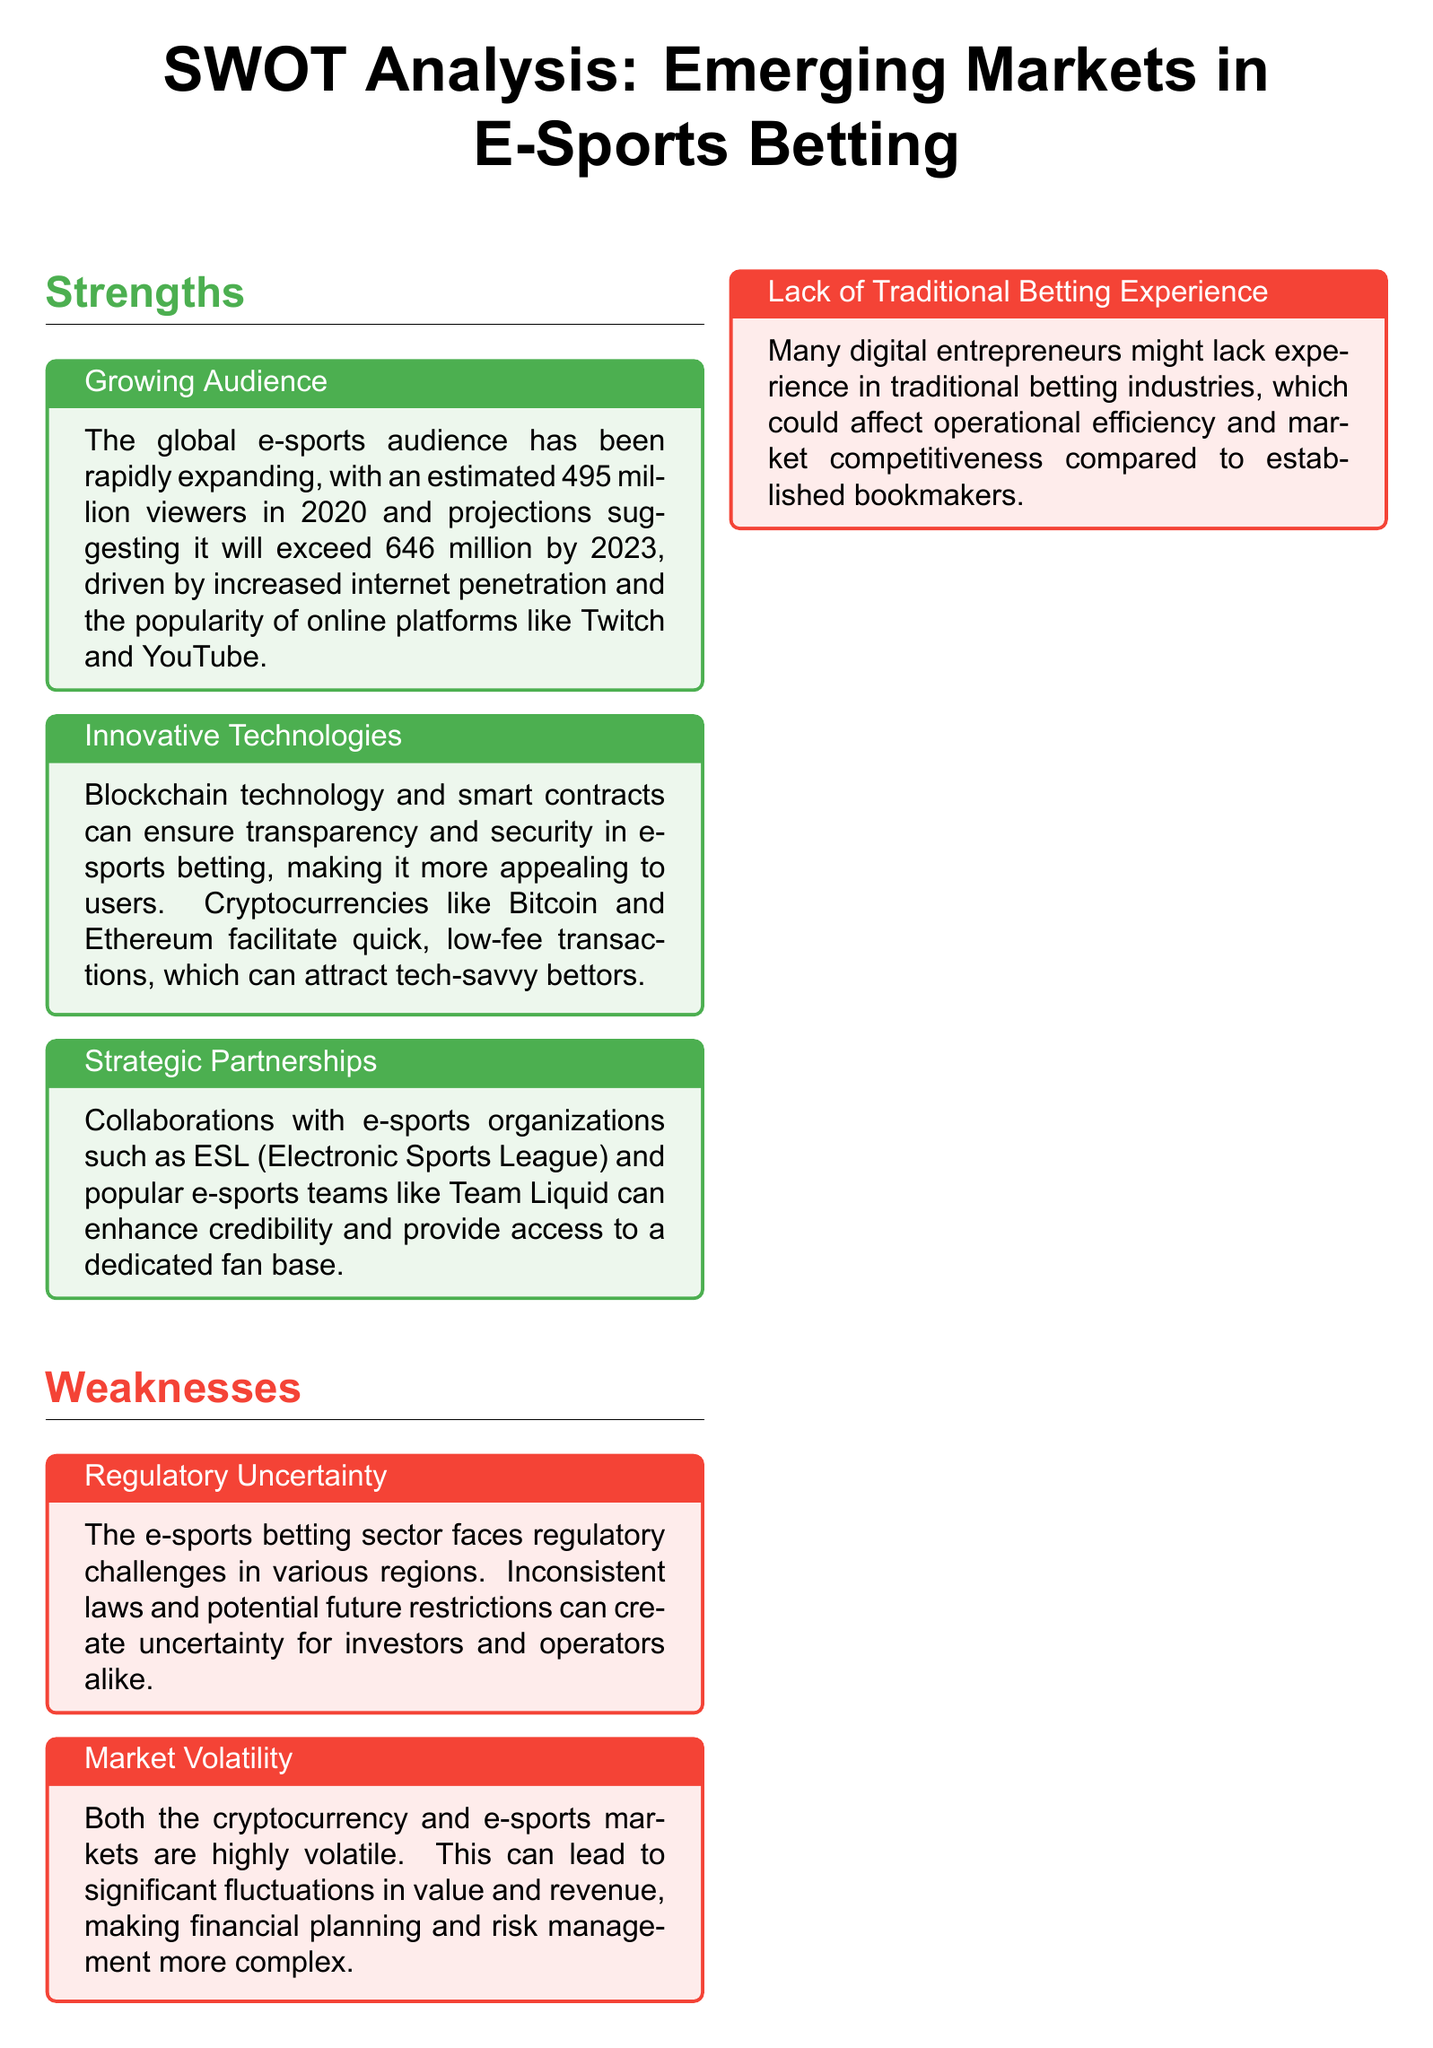What is the estimated global e-sports audience in 2023? According to the document, the estimated global e-sports audience is projected to exceed 646 million by 2023.
Answer: 646 million What technology is mentioned as ensuring transparency in e-sports betting? The document states that blockchain technology and smart contracts ensure transparency in e-sports betting.
Answer: Blockchain technology What is a notable strength related to audience growth? The document highlights a growing e-sports audience as a strength, with an estimated 495 million viewers in 2020.
Answer: Growing audience Name a weakness concerning market stability. The document discusses market volatility as a weakness, referring to both cryptocurrency and e-sports markets being highly volatile.
Answer: Market volatility Which regions show significant potential for new market penetration? The document mentions Southeast Asia, Latin America, and Africa as regions with growth potential in e-sports and cryptocurrency.
Answer: Southeast Asia, Latin America, and Africa What is a key threat identified in the document? Cybersecurity risks are listed as a key threat due to the risk of cyber attacks and fraud in e-sports betting platforms.
Answer: Cybersecurity risks How can brands outside the e-sports ecosystem contribute? The document states that collaborating with mainstream brands can provide additional marketing and revenue opportunities.
Answer: Brand partnerships What challenge does the e-sports betting sector face regarding regulations? The document points out regulatory uncertainty as a challenge due to inconsistent laws and potential restrictions.
Answer: Regulatory uncertainty What innovative feature can attract tech-savvy bettors according to the document? The document mentions cryptocurrencies facilitating quick, low-fee transactions as an innovative feature attracting tech-savvy bettors.
Answer: Cryptocurrencies 